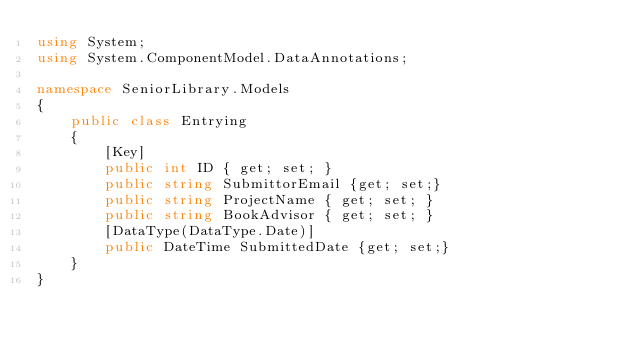Convert code to text. <code><loc_0><loc_0><loc_500><loc_500><_C#_>using System;
using System.ComponentModel.DataAnnotations;

namespace SeniorLibrary.Models
{
    public class Entrying
    {        
        [Key]
        public int ID { get; set; }
        public string SubmittorEmail {get; set;}
        public string ProjectName { get; set; }
        public string BookAdvisor { get; set; }
        [DataType(DataType.Date)]
        public DateTime SubmittedDate {get; set;}
    }
}</code> 